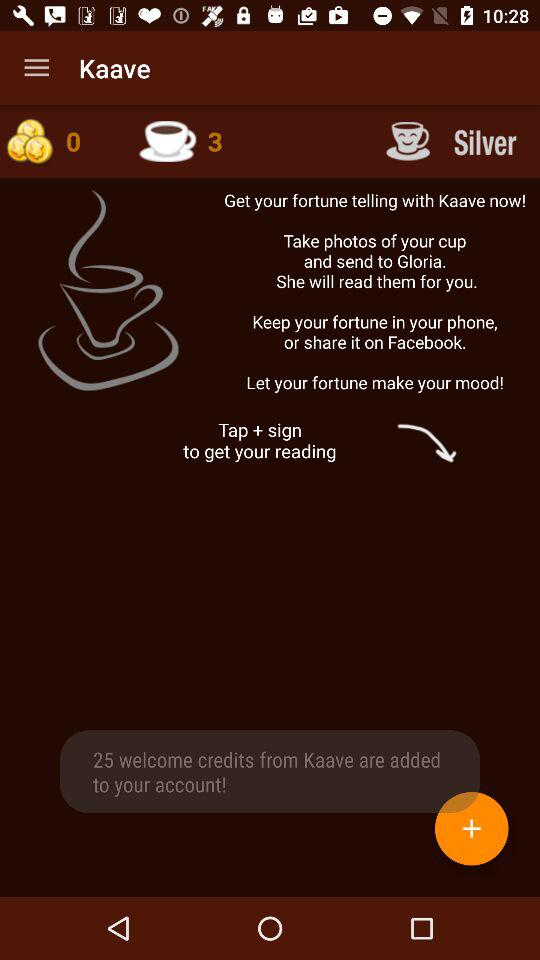How many more credits are there after the user clicks the plus sign?
Answer the question using a single word or phrase. 25 